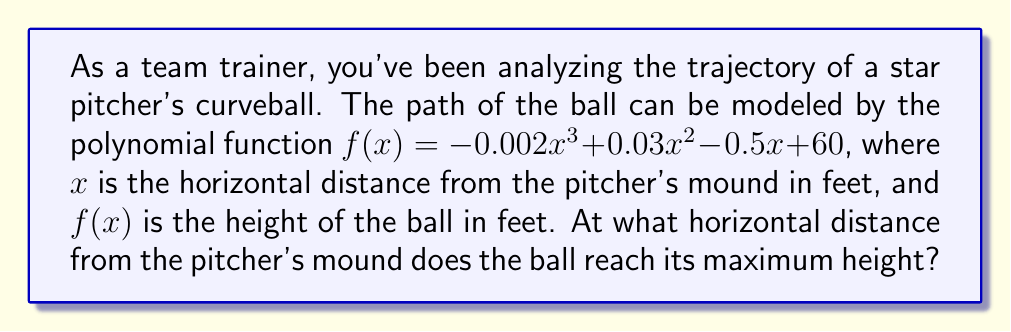Give your solution to this math problem. To find the maximum height of the curveball, we need to determine where the derivative of the function equals zero. This point represents the vertex of the parabola formed by the ball's trajectory.

1) First, let's find the derivative of $f(x)$:
   $$f'(x) = -0.006x^2 + 0.06x - 0.5$$

2) Set the derivative equal to zero:
   $$-0.006x^2 + 0.06x - 0.5 = 0$$

3) This is a quadratic equation. We can solve it using the quadratic formula:
   $$x = \frac{-b \pm \sqrt{b^2 - 4ac}}{2a}$$
   where $a = -0.006$, $b = 0.06$, and $c = -0.5$

4) Plugging in these values:
   $$x = \frac{-0.06 \pm \sqrt{0.06^2 - 4(-0.006)(-0.5)}}{2(-0.006)}$$

5) Simplifying:
   $$x = \frac{-0.06 \pm \sqrt{0.0036 - 0.012}}{-0.012}$$
   $$x = \frac{-0.06 \pm \sqrt{-0.0084}}{-0.012}$$

6) Since we're dealing with real distances, we can discard the negative solution under the square root. This means there's only one real solution:
   $$x = \frac{-0.06}{-0.012} = 5$$

Therefore, the ball reaches its maximum height when $x = 5$ feet from the pitcher's mound.
Answer: 5 feet 